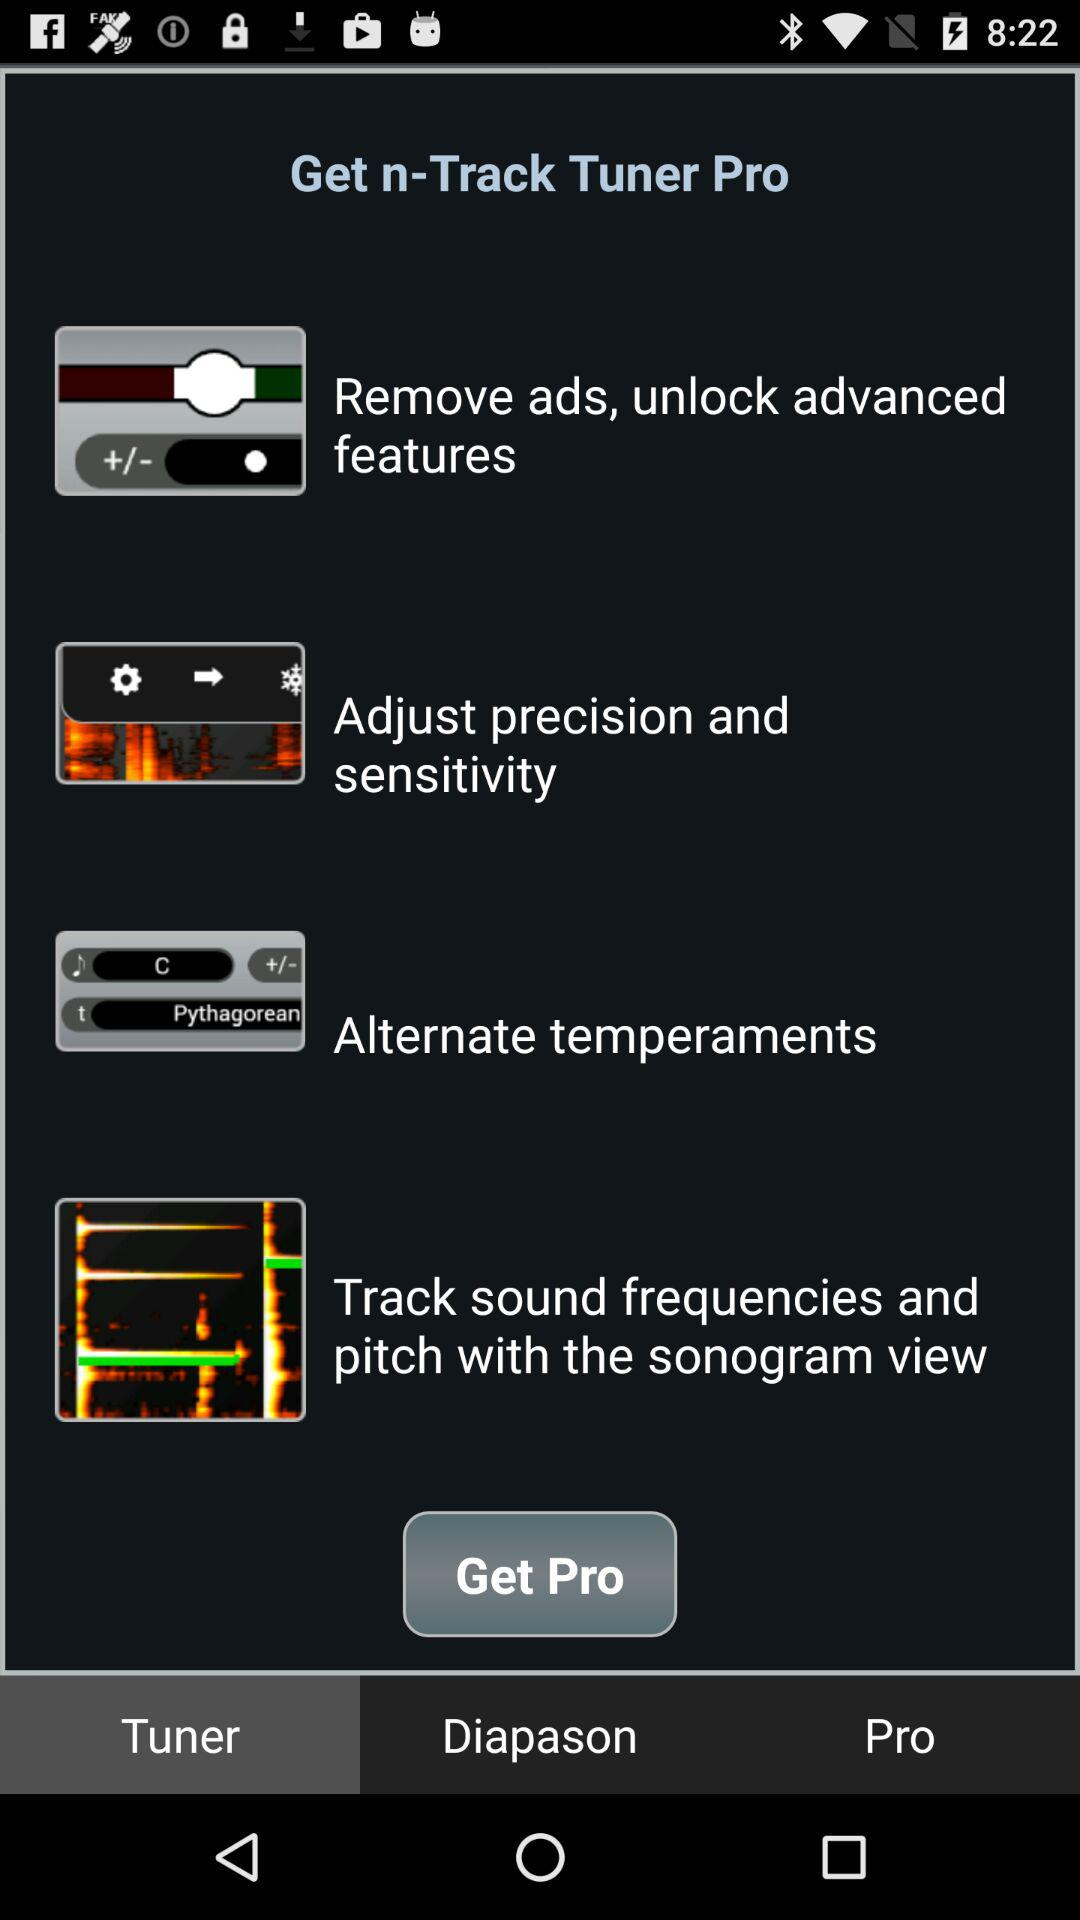How many features are unlocked with the Pro version?
Answer the question using a single word or phrase. 4 